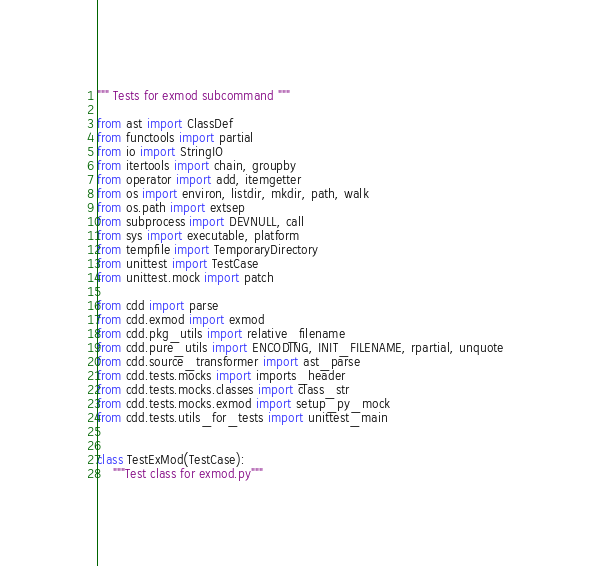<code> <loc_0><loc_0><loc_500><loc_500><_Python_>""" Tests for exmod subcommand """

from ast import ClassDef
from functools import partial
from io import StringIO
from itertools import chain, groupby
from operator import add, itemgetter
from os import environ, listdir, mkdir, path, walk
from os.path import extsep
from subprocess import DEVNULL, call
from sys import executable, platform
from tempfile import TemporaryDirectory
from unittest import TestCase
from unittest.mock import patch

from cdd import parse
from cdd.exmod import exmod
from cdd.pkg_utils import relative_filename
from cdd.pure_utils import ENCODING, INIT_FILENAME, rpartial, unquote
from cdd.source_transformer import ast_parse
from cdd.tests.mocks import imports_header
from cdd.tests.mocks.classes import class_str
from cdd.tests.mocks.exmod import setup_py_mock
from cdd.tests.utils_for_tests import unittest_main


class TestExMod(TestCase):
    """Test class for exmod.py"""
</code> 